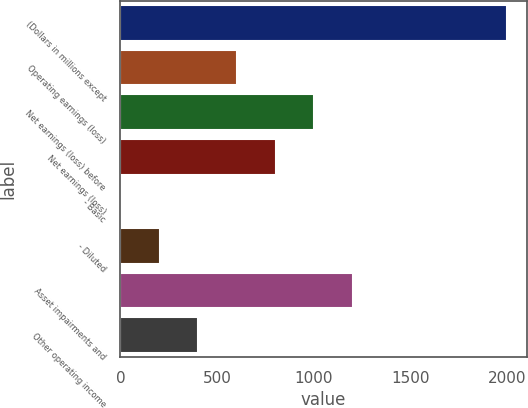Convert chart. <chart><loc_0><loc_0><loc_500><loc_500><bar_chart><fcel>(Dollars in millions except<fcel>Operating earnings (loss)<fcel>Net earnings (loss) before<fcel>Net earnings (loss)<fcel>- Basic<fcel>- Diluted<fcel>Asset impairments and<fcel>Other operating income<nl><fcel>2003<fcel>603.35<fcel>1003.25<fcel>803.3<fcel>3.5<fcel>203.45<fcel>1203.2<fcel>403.4<nl></chart> 